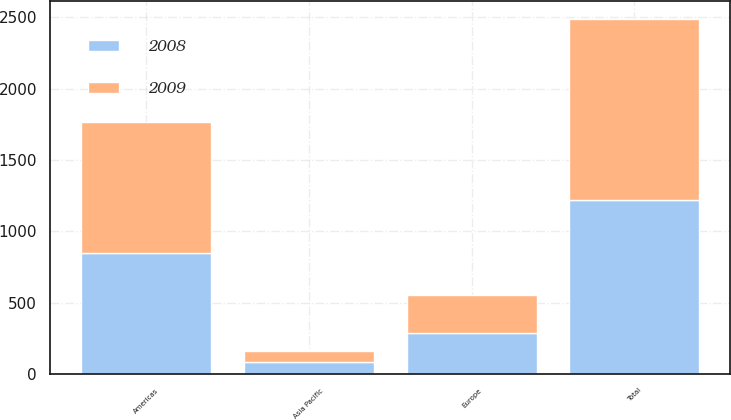<chart> <loc_0><loc_0><loc_500><loc_500><stacked_bar_chart><ecel><fcel>Americas<fcel>Europe<fcel>Asia Pacific<fcel>Total<nl><fcel>2008<fcel>851<fcel>285<fcel>85.7<fcel>1221.7<nl><fcel>2009<fcel>918.3<fcel>272.5<fcel>73.3<fcel>1264.1<nl></chart> 